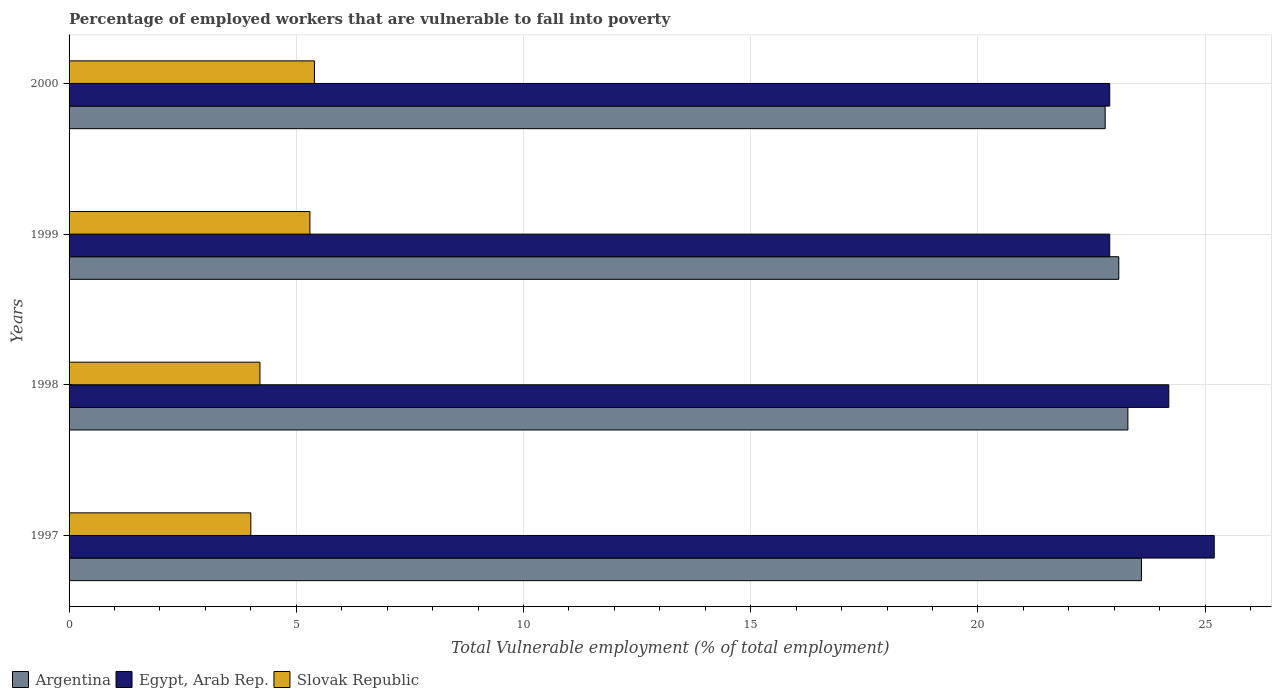Are the number of bars per tick equal to the number of legend labels?
Provide a succinct answer. Yes. What is the label of the 3rd group of bars from the top?
Offer a terse response. 1998. What is the percentage of employed workers who are vulnerable to fall into poverty in Argentina in 1999?
Your response must be concise. 23.1. Across all years, what is the maximum percentage of employed workers who are vulnerable to fall into poverty in Slovak Republic?
Your answer should be very brief. 5.4. Across all years, what is the minimum percentage of employed workers who are vulnerable to fall into poverty in Egypt, Arab Rep.?
Provide a succinct answer. 22.9. What is the total percentage of employed workers who are vulnerable to fall into poverty in Argentina in the graph?
Offer a terse response. 92.8. What is the difference between the percentage of employed workers who are vulnerable to fall into poverty in Argentina in 1998 and that in 2000?
Your answer should be very brief. 0.5. What is the difference between the percentage of employed workers who are vulnerable to fall into poverty in Argentina in 1997 and the percentage of employed workers who are vulnerable to fall into poverty in Egypt, Arab Rep. in 1998?
Ensure brevity in your answer.  -0.6. What is the average percentage of employed workers who are vulnerable to fall into poverty in Egypt, Arab Rep. per year?
Offer a terse response. 23.8. In the year 1998, what is the difference between the percentage of employed workers who are vulnerable to fall into poverty in Egypt, Arab Rep. and percentage of employed workers who are vulnerable to fall into poverty in Argentina?
Offer a very short reply. 0.9. What is the ratio of the percentage of employed workers who are vulnerable to fall into poverty in Argentina in 1997 to that in 1998?
Provide a succinct answer. 1.01. Is the percentage of employed workers who are vulnerable to fall into poverty in Slovak Republic in 1997 less than that in 2000?
Ensure brevity in your answer.  Yes. What is the difference between the highest and the lowest percentage of employed workers who are vulnerable to fall into poverty in Argentina?
Provide a short and direct response. 0.8. Is the sum of the percentage of employed workers who are vulnerable to fall into poverty in Egypt, Arab Rep. in 1999 and 2000 greater than the maximum percentage of employed workers who are vulnerable to fall into poverty in Argentina across all years?
Your answer should be compact. Yes. What does the 2nd bar from the top in 1997 represents?
Your answer should be compact. Egypt, Arab Rep. What does the 2nd bar from the bottom in 1998 represents?
Give a very brief answer. Egypt, Arab Rep. Is it the case that in every year, the sum of the percentage of employed workers who are vulnerable to fall into poverty in Egypt, Arab Rep. and percentage of employed workers who are vulnerable to fall into poverty in Slovak Republic is greater than the percentage of employed workers who are vulnerable to fall into poverty in Argentina?
Your response must be concise. Yes. Are all the bars in the graph horizontal?
Provide a succinct answer. Yes. How many years are there in the graph?
Your answer should be compact. 4. What is the difference between two consecutive major ticks on the X-axis?
Provide a succinct answer. 5. Are the values on the major ticks of X-axis written in scientific E-notation?
Provide a short and direct response. No. What is the title of the graph?
Your answer should be very brief. Percentage of employed workers that are vulnerable to fall into poverty. What is the label or title of the X-axis?
Offer a terse response. Total Vulnerable employment (% of total employment). What is the label or title of the Y-axis?
Give a very brief answer. Years. What is the Total Vulnerable employment (% of total employment) in Argentina in 1997?
Your answer should be compact. 23.6. What is the Total Vulnerable employment (% of total employment) of Egypt, Arab Rep. in 1997?
Offer a terse response. 25.2. What is the Total Vulnerable employment (% of total employment) in Argentina in 1998?
Provide a short and direct response. 23.3. What is the Total Vulnerable employment (% of total employment) of Egypt, Arab Rep. in 1998?
Keep it short and to the point. 24.2. What is the Total Vulnerable employment (% of total employment) of Slovak Republic in 1998?
Your answer should be compact. 4.2. What is the Total Vulnerable employment (% of total employment) in Argentina in 1999?
Make the answer very short. 23.1. What is the Total Vulnerable employment (% of total employment) of Egypt, Arab Rep. in 1999?
Offer a very short reply. 22.9. What is the Total Vulnerable employment (% of total employment) in Slovak Republic in 1999?
Keep it short and to the point. 5.3. What is the Total Vulnerable employment (% of total employment) of Argentina in 2000?
Offer a terse response. 22.8. What is the Total Vulnerable employment (% of total employment) of Egypt, Arab Rep. in 2000?
Your answer should be very brief. 22.9. What is the Total Vulnerable employment (% of total employment) of Slovak Republic in 2000?
Your answer should be compact. 5.4. Across all years, what is the maximum Total Vulnerable employment (% of total employment) of Argentina?
Provide a short and direct response. 23.6. Across all years, what is the maximum Total Vulnerable employment (% of total employment) of Egypt, Arab Rep.?
Your answer should be compact. 25.2. Across all years, what is the maximum Total Vulnerable employment (% of total employment) of Slovak Republic?
Provide a succinct answer. 5.4. Across all years, what is the minimum Total Vulnerable employment (% of total employment) in Argentina?
Keep it short and to the point. 22.8. Across all years, what is the minimum Total Vulnerable employment (% of total employment) in Egypt, Arab Rep.?
Your answer should be compact. 22.9. Across all years, what is the minimum Total Vulnerable employment (% of total employment) in Slovak Republic?
Offer a terse response. 4. What is the total Total Vulnerable employment (% of total employment) in Argentina in the graph?
Offer a terse response. 92.8. What is the total Total Vulnerable employment (% of total employment) of Egypt, Arab Rep. in the graph?
Your answer should be compact. 95.2. What is the total Total Vulnerable employment (% of total employment) of Slovak Republic in the graph?
Keep it short and to the point. 18.9. What is the difference between the Total Vulnerable employment (% of total employment) of Egypt, Arab Rep. in 1997 and that in 1998?
Provide a succinct answer. 1. What is the difference between the Total Vulnerable employment (% of total employment) of Argentina in 1997 and that in 1999?
Offer a terse response. 0.5. What is the difference between the Total Vulnerable employment (% of total employment) in Argentina in 1997 and that in 2000?
Offer a terse response. 0.8. What is the difference between the Total Vulnerable employment (% of total employment) of Argentina in 1998 and that in 2000?
Ensure brevity in your answer.  0.5. What is the difference between the Total Vulnerable employment (% of total employment) in Slovak Republic in 1998 and that in 2000?
Offer a terse response. -1.2. What is the difference between the Total Vulnerable employment (% of total employment) in Argentina in 1999 and that in 2000?
Make the answer very short. 0.3. What is the difference between the Total Vulnerable employment (% of total employment) in Egypt, Arab Rep. in 1999 and that in 2000?
Offer a terse response. 0. What is the difference between the Total Vulnerable employment (% of total employment) of Slovak Republic in 1999 and that in 2000?
Keep it short and to the point. -0.1. What is the difference between the Total Vulnerable employment (% of total employment) in Egypt, Arab Rep. in 1997 and the Total Vulnerable employment (% of total employment) in Slovak Republic in 1998?
Provide a succinct answer. 21. What is the difference between the Total Vulnerable employment (% of total employment) of Argentina in 1997 and the Total Vulnerable employment (% of total employment) of Egypt, Arab Rep. in 1999?
Your answer should be very brief. 0.7. What is the difference between the Total Vulnerable employment (% of total employment) of Argentina in 1997 and the Total Vulnerable employment (% of total employment) of Slovak Republic in 1999?
Provide a succinct answer. 18.3. What is the difference between the Total Vulnerable employment (% of total employment) in Egypt, Arab Rep. in 1997 and the Total Vulnerable employment (% of total employment) in Slovak Republic in 2000?
Your answer should be compact. 19.8. What is the difference between the Total Vulnerable employment (% of total employment) in Argentina in 1998 and the Total Vulnerable employment (% of total employment) in Slovak Republic in 1999?
Your answer should be compact. 18. What is the difference between the Total Vulnerable employment (% of total employment) of Egypt, Arab Rep. in 1998 and the Total Vulnerable employment (% of total employment) of Slovak Republic in 1999?
Your response must be concise. 18.9. What is the difference between the Total Vulnerable employment (% of total employment) in Argentina in 1998 and the Total Vulnerable employment (% of total employment) in Egypt, Arab Rep. in 2000?
Your response must be concise. 0.4. What is the difference between the Total Vulnerable employment (% of total employment) of Egypt, Arab Rep. in 1998 and the Total Vulnerable employment (% of total employment) of Slovak Republic in 2000?
Provide a short and direct response. 18.8. What is the difference between the Total Vulnerable employment (% of total employment) in Argentina in 1999 and the Total Vulnerable employment (% of total employment) in Egypt, Arab Rep. in 2000?
Your response must be concise. 0.2. What is the difference between the Total Vulnerable employment (% of total employment) of Argentina in 1999 and the Total Vulnerable employment (% of total employment) of Slovak Republic in 2000?
Provide a short and direct response. 17.7. What is the difference between the Total Vulnerable employment (% of total employment) in Egypt, Arab Rep. in 1999 and the Total Vulnerable employment (% of total employment) in Slovak Republic in 2000?
Give a very brief answer. 17.5. What is the average Total Vulnerable employment (% of total employment) in Argentina per year?
Your answer should be very brief. 23.2. What is the average Total Vulnerable employment (% of total employment) of Egypt, Arab Rep. per year?
Provide a succinct answer. 23.8. What is the average Total Vulnerable employment (% of total employment) of Slovak Republic per year?
Keep it short and to the point. 4.72. In the year 1997, what is the difference between the Total Vulnerable employment (% of total employment) in Argentina and Total Vulnerable employment (% of total employment) in Slovak Republic?
Offer a terse response. 19.6. In the year 1997, what is the difference between the Total Vulnerable employment (% of total employment) in Egypt, Arab Rep. and Total Vulnerable employment (% of total employment) in Slovak Republic?
Offer a very short reply. 21.2. In the year 1998, what is the difference between the Total Vulnerable employment (% of total employment) in Argentina and Total Vulnerable employment (% of total employment) in Egypt, Arab Rep.?
Provide a succinct answer. -0.9. In the year 1998, what is the difference between the Total Vulnerable employment (% of total employment) in Egypt, Arab Rep. and Total Vulnerable employment (% of total employment) in Slovak Republic?
Provide a short and direct response. 20. In the year 1999, what is the difference between the Total Vulnerable employment (% of total employment) in Argentina and Total Vulnerable employment (% of total employment) in Egypt, Arab Rep.?
Offer a very short reply. 0.2. In the year 1999, what is the difference between the Total Vulnerable employment (% of total employment) of Argentina and Total Vulnerable employment (% of total employment) of Slovak Republic?
Offer a very short reply. 17.8. In the year 2000, what is the difference between the Total Vulnerable employment (% of total employment) in Argentina and Total Vulnerable employment (% of total employment) in Egypt, Arab Rep.?
Make the answer very short. -0.1. In the year 2000, what is the difference between the Total Vulnerable employment (% of total employment) of Egypt, Arab Rep. and Total Vulnerable employment (% of total employment) of Slovak Republic?
Your response must be concise. 17.5. What is the ratio of the Total Vulnerable employment (% of total employment) of Argentina in 1997 to that in 1998?
Provide a short and direct response. 1.01. What is the ratio of the Total Vulnerable employment (% of total employment) in Egypt, Arab Rep. in 1997 to that in 1998?
Give a very brief answer. 1.04. What is the ratio of the Total Vulnerable employment (% of total employment) in Argentina in 1997 to that in 1999?
Your response must be concise. 1.02. What is the ratio of the Total Vulnerable employment (% of total employment) in Egypt, Arab Rep. in 1997 to that in 1999?
Provide a short and direct response. 1.1. What is the ratio of the Total Vulnerable employment (% of total employment) of Slovak Republic in 1997 to that in 1999?
Keep it short and to the point. 0.75. What is the ratio of the Total Vulnerable employment (% of total employment) in Argentina in 1997 to that in 2000?
Offer a terse response. 1.04. What is the ratio of the Total Vulnerable employment (% of total employment) of Egypt, Arab Rep. in 1997 to that in 2000?
Your response must be concise. 1.1. What is the ratio of the Total Vulnerable employment (% of total employment) of Slovak Republic in 1997 to that in 2000?
Your answer should be very brief. 0.74. What is the ratio of the Total Vulnerable employment (% of total employment) in Argentina in 1998 to that in 1999?
Provide a succinct answer. 1.01. What is the ratio of the Total Vulnerable employment (% of total employment) in Egypt, Arab Rep. in 1998 to that in 1999?
Keep it short and to the point. 1.06. What is the ratio of the Total Vulnerable employment (% of total employment) of Slovak Republic in 1998 to that in 1999?
Provide a succinct answer. 0.79. What is the ratio of the Total Vulnerable employment (% of total employment) of Argentina in 1998 to that in 2000?
Offer a very short reply. 1.02. What is the ratio of the Total Vulnerable employment (% of total employment) in Egypt, Arab Rep. in 1998 to that in 2000?
Make the answer very short. 1.06. What is the ratio of the Total Vulnerable employment (% of total employment) of Argentina in 1999 to that in 2000?
Offer a terse response. 1.01. What is the ratio of the Total Vulnerable employment (% of total employment) of Slovak Republic in 1999 to that in 2000?
Provide a succinct answer. 0.98. What is the difference between the highest and the second highest Total Vulnerable employment (% of total employment) of Egypt, Arab Rep.?
Offer a terse response. 1. What is the difference between the highest and the lowest Total Vulnerable employment (% of total employment) of Argentina?
Keep it short and to the point. 0.8. What is the difference between the highest and the lowest Total Vulnerable employment (% of total employment) of Egypt, Arab Rep.?
Ensure brevity in your answer.  2.3. What is the difference between the highest and the lowest Total Vulnerable employment (% of total employment) of Slovak Republic?
Provide a short and direct response. 1.4. 